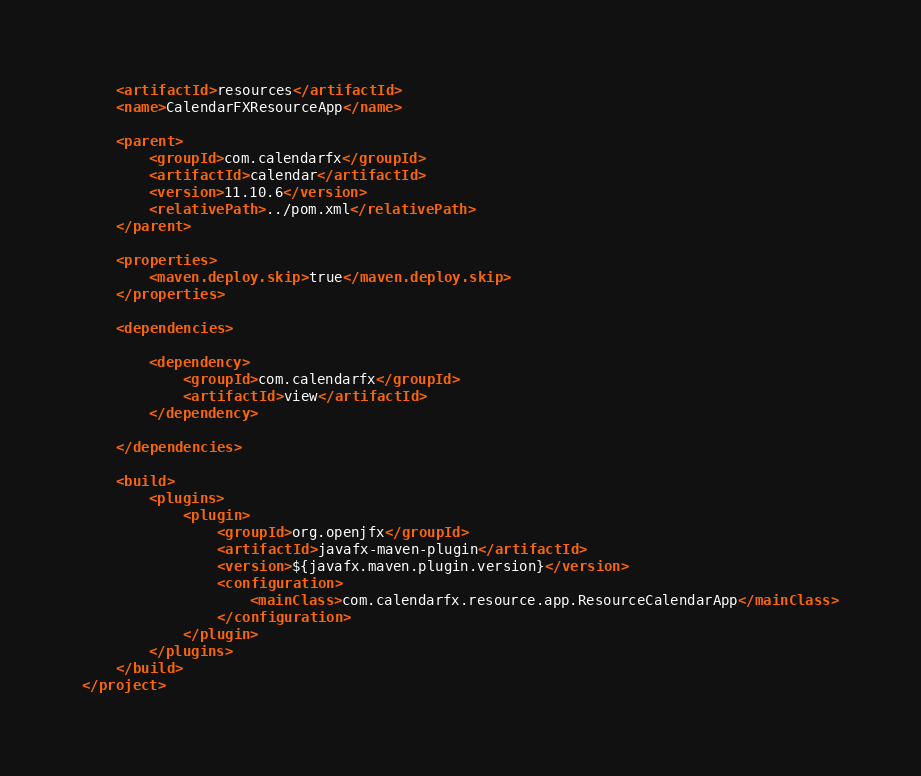Convert code to text. <code><loc_0><loc_0><loc_500><loc_500><_XML_>    <artifactId>resources</artifactId>
    <name>CalendarFXResourceApp</name>

    <parent>
        <groupId>com.calendarfx</groupId>
        <artifactId>calendar</artifactId>
        <version>11.10.6</version>
        <relativePath>../pom.xml</relativePath>
    </parent>

    <properties>
        <maven.deploy.skip>true</maven.deploy.skip>
    </properties>

    <dependencies>

        <dependency>
            <groupId>com.calendarfx</groupId>
            <artifactId>view</artifactId>
        </dependency>

    </dependencies>

    <build>
        <plugins>
            <plugin>
                <groupId>org.openjfx</groupId>
                <artifactId>javafx-maven-plugin</artifactId>
                <version>${javafx.maven.plugin.version}</version>
                <configuration>
                    <mainClass>com.calendarfx.resource.app.ResourceCalendarApp</mainClass>
                </configuration>
            </plugin>
        </plugins>
    </build>
</project></code> 